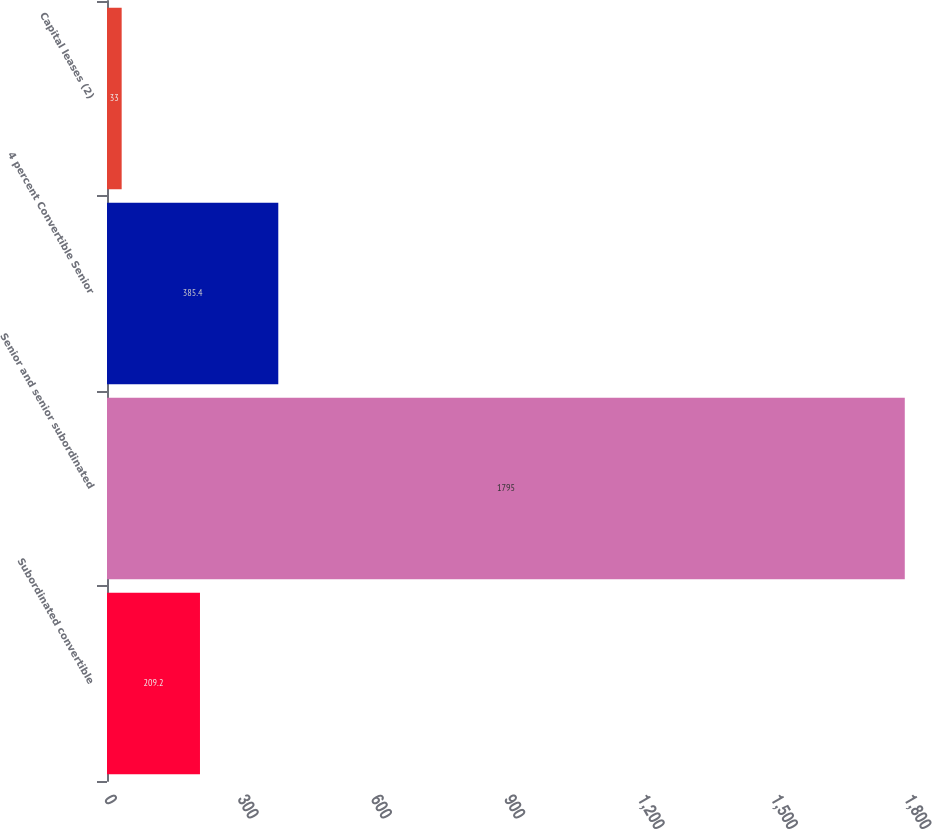Convert chart to OTSL. <chart><loc_0><loc_0><loc_500><loc_500><bar_chart><fcel>Subordinated convertible<fcel>Senior and senior subordinated<fcel>4 percent Convertible Senior<fcel>Capital leases (2)<nl><fcel>209.2<fcel>1795<fcel>385.4<fcel>33<nl></chart> 